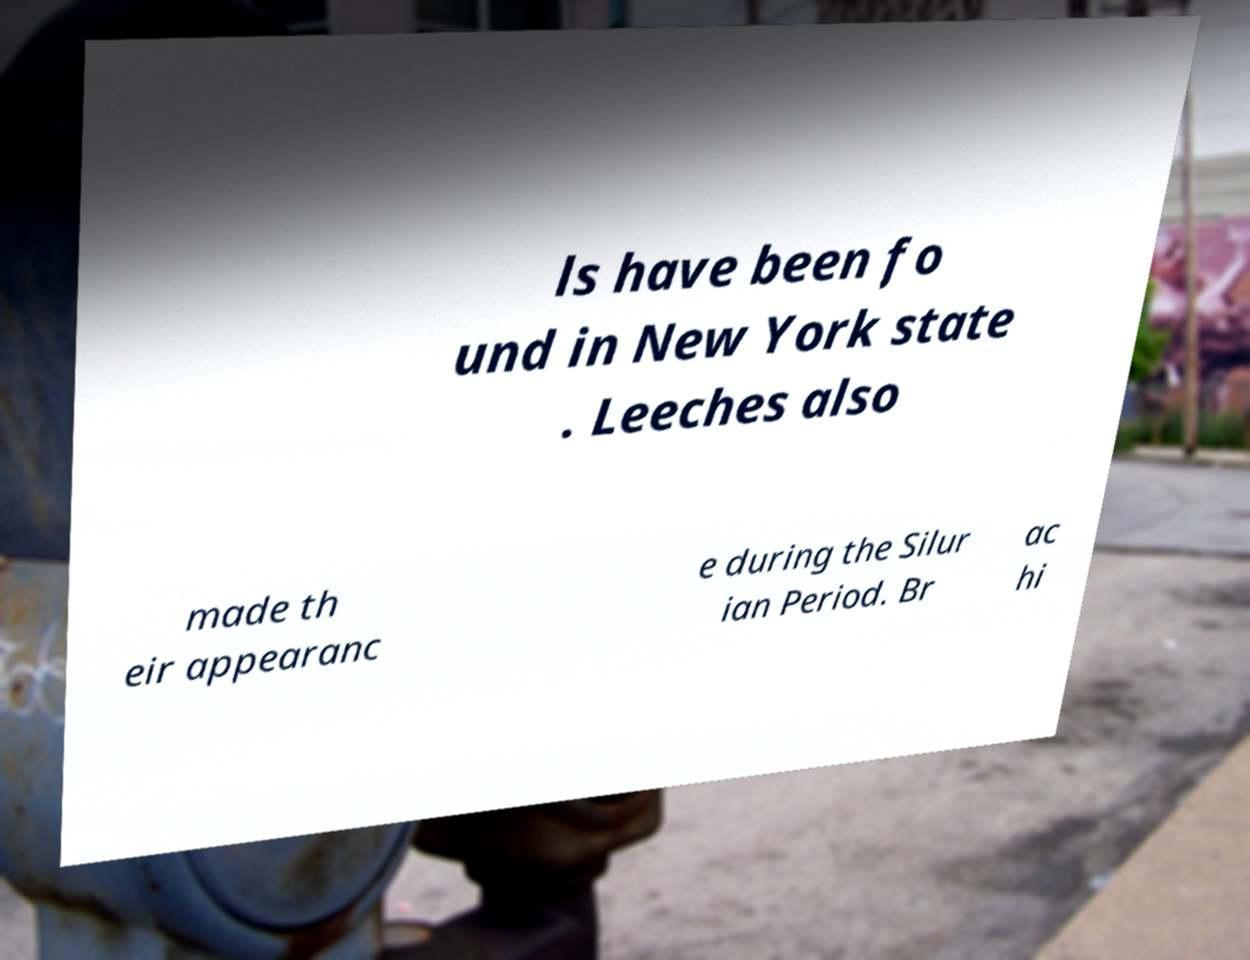Please identify and transcribe the text found in this image. ls have been fo und in New York state . Leeches also made th eir appearanc e during the Silur ian Period. Br ac hi 